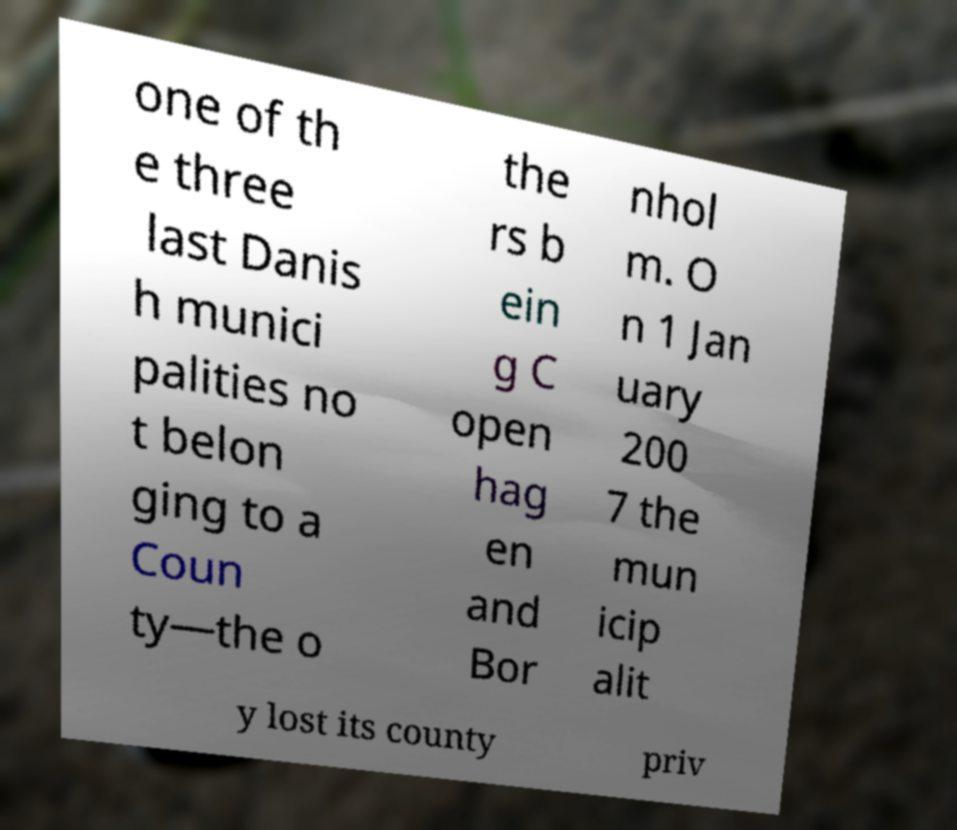Please identify and transcribe the text found in this image. one of th e three last Danis h munici palities no t belon ging to a Coun ty—the o the rs b ein g C open hag en and Bor nhol m. O n 1 Jan uary 200 7 the mun icip alit y lost its county priv 